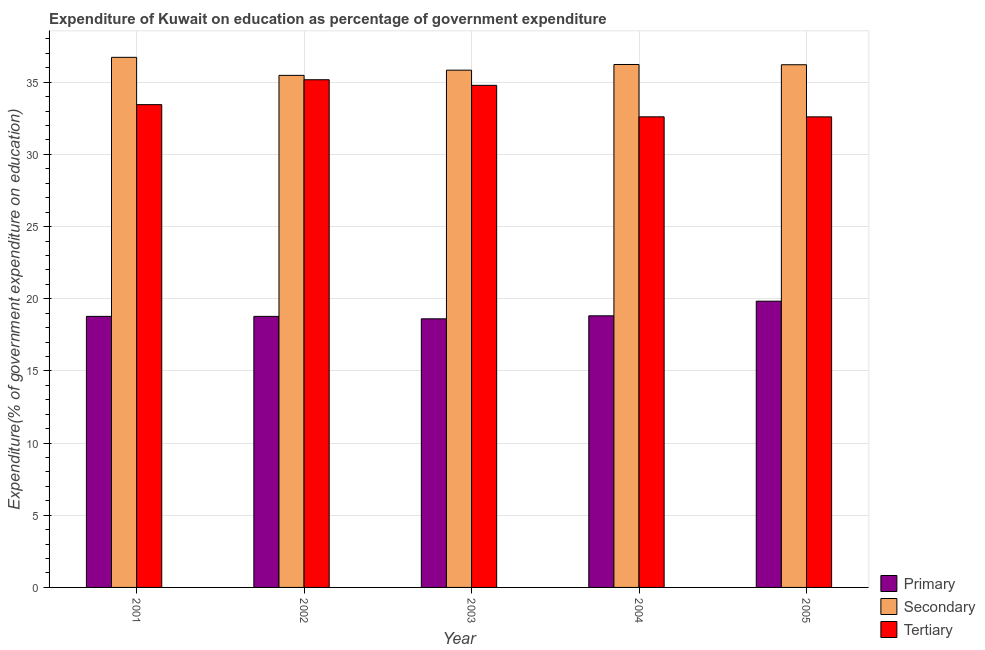How many different coloured bars are there?
Make the answer very short. 3. Are the number of bars on each tick of the X-axis equal?
Your response must be concise. Yes. How many bars are there on the 5th tick from the left?
Provide a succinct answer. 3. What is the expenditure on primary education in 2002?
Ensure brevity in your answer.  18.78. Across all years, what is the maximum expenditure on primary education?
Your response must be concise. 19.83. Across all years, what is the minimum expenditure on secondary education?
Offer a terse response. 35.48. In which year was the expenditure on secondary education maximum?
Give a very brief answer. 2001. In which year was the expenditure on primary education minimum?
Provide a short and direct response. 2003. What is the total expenditure on secondary education in the graph?
Provide a succinct answer. 180.48. What is the difference between the expenditure on tertiary education in 2003 and that in 2004?
Give a very brief answer. 2.18. What is the difference between the expenditure on primary education in 2003 and the expenditure on tertiary education in 2004?
Your response must be concise. -0.21. What is the average expenditure on tertiary education per year?
Give a very brief answer. 33.72. In the year 2001, what is the difference between the expenditure on secondary education and expenditure on tertiary education?
Offer a terse response. 0. In how many years, is the expenditure on tertiary education greater than 5 %?
Provide a short and direct response. 5. What is the ratio of the expenditure on tertiary education in 2001 to that in 2002?
Your answer should be very brief. 0.95. Is the difference between the expenditure on tertiary education in 2001 and 2004 greater than the difference between the expenditure on primary education in 2001 and 2004?
Your answer should be very brief. No. What is the difference between the highest and the second highest expenditure on tertiary education?
Provide a succinct answer. 0.39. What is the difference between the highest and the lowest expenditure on primary education?
Keep it short and to the point. 1.22. Is the sum of the expenditure on tertiary education in 2002 and 2003 greater than the maximum expenditure on secondary education across all years?
Your answer should be very brief. Yes. What does the 2nd bar from the left in 2001 represents?
Your answer should be very brief. Secondary. What does the 2nd bar from the right in 2004 represents?
Ensure brevity in your answer.  Secondary. Is it the case that in every year, the sum of the expenditure on primary education and expenditure on secondary education is greater than the expenditure on tertiary education?
Offer a very short reply. Yes. Are the values on the major ticks of Y-axis written in scientific E-notation?
Offer a terse response. No. Does the graph contain grids?
Offer a terse response. Yes. How many legend labels are there?
Keep it short and to the point. 3. How are the legend labels stacked?
Your response must be concise. Vertical. What is the title of the graph?
Your answer should be very brief. Expenditure of Kuwait on education as percentage of government expenditure. Does "Total employers" appear as one of the legend labels in the graph?
Your answer should be compact. No. What is the label or title of the X-axis?
Offer a very short reply. Year. What is the label or title of the Y-axis?
Your response must be concise. Expenditure(% of government expenditure on education). What is the Expenditure(% of government expenditure on education) of Primary in 2001?
Give a very brief answer. 18.78. What is the Expenditure(% of government expenditure on education) of Secondary in 2001?
Keep it short and to the point. 36.73. What is the Expenditure(% of government expenditure on education) of Tertiary in 2001?
Your answer should be compact. 33.45. What is the Expenditure(% of government expenditure on education) in Primary in 2002?
Your answer should be compact. 18.78. What is the Expenditure(% of government expenditure on education) in Secondary in 2002?
Your response must be concise. 35.48. What is the Expenditure(% of government expenditure on education) in Tertiary in 2002?
Your answer should be compact. 35.17. What is the Expenditure(% of government expenditure on education) of Primary in 2003?
Your answer should be compact. 18.61. What is the Expenditure(% of government expenditure on education) in Secondary in 2003?
Your response must be concise. 35.84. What is the Expenditure(% of government expenditure on education) of Tertiary in 2003?
Your answer should be compact. 34.79. What is the Expenditure(% of government expenditure on education) in Primary in 2004?
Give a very brief answer. 18.82. What is the Expenditure(% of government expenditure on education) of Secondary in 2004?
Your answer should be compact. 36.23. What is the Expenditure(% of government expenditure on education) of Tertiary in 2004?
Provide a short and direct response. 32.6. What is the Expenditure(% of government expenditure on education) in Primary in 2005?
Offer a terse response. 19.83. What is the Expenditure(% of government expenditure on education) in Secondary in 2005?
Give a very brief answer. 36.21. What is the Expenditure(% of government expenditure on education) of Tertiary in 2005?
Offer a very short reply. 32.6. Across all years, what is the maximum Expenditure(% of government expenditure on education) of Primary?
Ensure brevity in your answer.  19.83. Across all years, what is the maximum Expenditure(% of government expenditure on education) of Secondary?
Keep it short and to the point. 36.73. Across all years, what is the maximum Expenditure(% of government expenditure on education) in Tertiary?
Keep it short and to the point. 35.17. Across all years, what is the minimum Expenditure(% of government expenditure on education) in Primary?
Give a very brief answer. 18.61. Across all years, what is the minimum Expenditure(% of government expenditure on education) of Secondary?
Ensure brevity in your answer.  35.48. Across all years, what is the minimum Expenditure(% of government expenditure on education) in Tertiary?
Provide a succinct answer. 32.6. What is the total Expenditure(% of government expenditure on education) of Primary in the graph?
Your response must be concise. 94.81. What is the total Expenditure(% of government expenditure on education) in Secondary in the graph?
Give a very brief answer. 180.48. What is the total Expenditure(% of government expenditure on education) in Tertiary in the graph?
Provide a short and direct response. 168.61. What is the difference between the Expenditure(% of government expenditure on education) of Primary in 2001 and that in 2002?
Offer a terse response. 0. What is the difference between the Expenditure(% of government expenditure on education) of Secondary in 2001 and that in 2002?
Give a very brief answer. 1.25. What is the difference between the Expenditure(% of government expenditure on education) of Tertiary in 2001 and that in 2002?
Provide a succinct answer. -1.73. What is the difference between the Expenditure(% of government expenditure on education) of Primary in 2001 and that in 2003?
Your answer should be very brief. 0.17. What is the difference between the Expenditure(% of government expenditure on education) of Secondary in 2001 and that in 2003?
Offer a terse response. 0.89. What is the difference between the Expenditure(% of government expenditure on education) in Tertiary in 2001 and that in 2003?
Make the answer very short. -1.34. What is the difference between the Expenditure(% of government expenditure on education) in Primary in 2001 and that in 2004?
Offer a terse response. -0.04. What is the difference between the Expenditure(% of government expenditure on education) in Secondary in 2001 and that in 2004?
Offer a very short reply. 0.5. What is the difference between the Expenditure(% of government expenditure on education) in Tertiary in 2001 and that in 2004?
Your answer should be compact. 0.84. What is the difference between the Expenditure(% of government expenditure on education) in Primary in 2001 and that in 2005?
Ensure brevity in your answer.  -1.05. What is the difference between the Expenditure(% of government expenditure on education) of Secondary in 2001 and that in 2005?
Offer a terse response. 0.51. What is the difference between the Expenditure(% of government expenditure on education) of Tertiary in 2001 and that in 2005?
Make the answer very short. 0.85. What is the difference between the Expenditure(% of government expenditure on education) of Primary in 2002 and that in 2003?
Make the answer very short. 0.17. What is the difference between the Expenditure(% of government expenditure on education) in Secondary in 2002 and that in 2003?
Provide a short and direct response. -0.36. What is the difference between the Expenditure(% of government expenditure on education) in Tertiary in 2002 and that in 2003?
Give a very brief answer. 0.39. What is the difference between the Expenditure(% of government expenditure on education) in Primary in 2002 and that in 2004?
Your answer should be very brief. -0.04. What is the difference between the Expenditure(% of government expenditure on education) of Secondary in 2002 and that in 2004?
Provide a short and direct response. -0.75. What is the difference between the Expenditure(% of government expenditure on education) of Tertiary in 2002 and that in 2004?
Your answer should be very brief. 2.57. What is the difference between the Expenditure(% of government expenditure on education) in Primary in 2002 and that in 2005?
Provide a short and direct response. -1.05. What is the difference between the Expenditure(% of government expenditure on education) in Secondary in 2002 and that in 2005?
Keep it short and to the point. -0.74. What is the difference between the Expenditure(% of government expenditure on education) of Tertiary in 2002 and that in 2005?
Offer a terse response. 2.57. What is the difference between the Expenditure(% of government expenditure on education) in Primary in 2003 and that in 2004?
Your answer should be very brief. -0.21. What is the difference between the Expenditure(% of government expenditure on education) in Secondary in 2003 and that in 2004?
Your answer should be compact. -0.39. What is the difference between the Expenditure(% of government expenditure on education) in Tertiary in 2003 and that in 2004?
Your response must be concise. 2.18. What is the difference between the Expenditure(% of government expenditure on education) of Primary in 2003 and that in 2005?
Make the answer very short. -1.22. What is the difference between the Expenditure(% of government expenditure on education) of Secondary in 2003 and that in 2005?
Give a very brief answer. -0.38. What is the difference between the Expenditure(% of government expenditure on education) of Tertiary in 2003 and that in 2005?
Your answer should be very brief. 2.18. What is the difference between the Expenditure(% of government expenditure on education) in Primary in 2004 and that in 2005?
Ensure brevity in your answer.  -1.01. What is the difference between the Expenditure(% of government expenditure on education) of Secondary in 2004 and that in 2005?
Keep it short and to the point. 0.02. What is the difference between the Expenditure(% of government expenditure on education) of Tertiary in 2004 and that in 2005?
Provide a succinct answer. 0. What is the difference between the Expenditure(% of government expenditure on education) in Primary in 2001 and the Expenditure(% of government expenditure on education) in Secondary in 2002?
Provide a short and direct response. -16.7. What is the difference between the Expenditure(% of government expenditure on education) in Primary in 2001 and the Expenditure(% of government expenditure on education) in Tertiary in 2002?
Your response must be concise. -16.39. What is the difference between the Expenditure(% of government expenditure on education) in Secondary in 2001 and the Expenditure(% of government expenditure on education) in Tertiary in 2002?
Make the answer very short. 1.55. What is the difference between the Expenditure(% of government expenditure on education) in Primary in 2001 and the Expenditure(% of government expenditure on education) in Secondary in 2003?
Your answer should be compact. -17.06. What is the difference between the Expenditure(% of government expenditure on education) of Primary in 2001 and the Expenditure(% of government expenditure on education) of Tertiary in 2003?
Provide a succinct answer. -16.01. What is the difference between the Expenditure(% of government expenditure on education) in Secondary in 2001 and the Expenditure(% of government expenditure on education) in Tertiary in 2003?
Keep it short and to the point. 1.94. What is the difference between the Expenditure(% of government expenditure on education) in Primary in 2001 and the Expenditure(% of government expenditure on education) in Secondary in 2004?
Your response must be concise. -17.45. What is the difference between the Expenditure(% of government expenditure on education) of Primary in 2001 and the Expenditure(% of government expenditure on education) of Tertiary in 2004?
Your answer should be very brief. -13.82. What is the difference between the Expenditure(% of government expenditure on education) in Secondary in 2001 and the Expenditure(% of government expenditure on education) in Tertiary in 2004?
Provide a short and direct response. 4.12. What is the difference between the Expenditure(% of government expenditure on education) of Primary in 2001 and the Expenditure(% of government expenditure on education) of Secondary in 2005?
Provide a short and direct response. -17.43. What is the difference between the Expenditure(% of government expenditure on education) of Primary in 2001 and the Expenditure(% of government expenditure on education) of Tertiary in 2005?
Your response must be concise. -13.82. What is the difference between the Expenditure(% of government expenditure on education) in Secondary in 2001 and the Expenditure(% of government expenditure on education) in Tertiary in 2005?
Offer a very short reply. 4.12. What is the difference between the Expenditure(% of government expenditure on education) in Primary in 2002 and the Expenditure(% of government expenditure on education) in Secondary in 2003?
Ensure brevity in your answer.  -17.06. What is the difference between the Expenditure(% of government expenditure on education) in Primary in 2002 and the Expenditure(% of government expenditure on education) in Tertiary in 2003?
Offer a very short reply. -16.01. What is the difference between the Expenditure(% of government expenditure on education) in Secondary in 2002 and the Expenditure(% of government expenditure on education) in Tertiary in 2003?
Your answer should be very brief. 0.69. What is the difference between the Expenditure(% of government expenditure on education) of Primary in 2002 and the Expenditure(% of government expenditure on education) of Secondary in 2004?
Make the answer very short. -17.45. What is the difference between the Expenditure(% of government expenditure on education) of Primary in 2002 and the Expenditure(% of government expenditure on education) of Tertiary in 2004?
Provide a succinct answer. -13.82. What is the difference between the Expenditure(% of government expenditure on education) of Secondary in 2002 and the Expenditure(% of government expenditure on education) of Tertiary in 2004?
Your response must be concise. 2.87. What is the difference between the Expenditure(% of government expenditure on education) of Primary in 2002 and the Expenditure(% of government expenditure on education) of Secondary in 2005?
Keep it short and to the point. -17.43. What is the difference between the Expenditure(% of government expenditure on education) of Primary in 2002 and the Expenditure(% of government expenditure on education) of Tertiary in 2005?
Provide a succinct answer. -13.82. What is the difference between the Expenditure(% of government expenditure on education) of Secondary in 2002 and the Expenditure(% of government expenditure on education) of Tertiary in 2005?
Provide a short and direct response. 2.88. What is the difference between the Expenditure(% of government expenditure on education) in Primary in 2003 and the Expenditure(% of government expenditure on education) in Secondary in 2004?
Offer a terse response. -17.62. What is the difference between the Expenditure(% of government expenditure on education) of Primary in 2003 and the Expenditure(% of government expenditure on education) of Tertiary in 2004?
Offer a very short reply. -13.99. What is the difference between the Expenditure(% of government expenditure on education) in Secondary in 2003 and the Expenditure(% of government expenditure on education) in Tertiary in 2004?
Keep it short and to the point. 3.23. What is the difference between the Expenditure(% of government expenditure on education) in Primary in 2003 and the Expenditure(% of government expenditure on education) in Secondary in 2005?
Your answer should be very brief. -17.6. What is the difference between the Expenditure(% of government expenditure on education) of Primary in 2003 and the Expenditure(% of government expenditure on education) of Tertiary in 2005?
Offer a very short reply. -13.99. What is the difference between the Expenditure(% of government expenditure on education) of Secondary in 2003 and the Expenditure(% of government expenditure on education) of Tertiary in 2005?
Provide a succinct answer. 3.24. What is the difference between the Expenditure(% of government expenditure on education) in Primary in 2004 and the Expenditure(% of government expenditure on education) in Secondary in 2005?
Provide a short and direct response. -17.39. What is the difference between the Expenditure(% of government expenditure on education) of Primary in 2004 and the Expenditure(% of government expenditure on education) of Tertiary in 2005?
Keep it short and to the point. -13.78. What is the difference between the Expenditure(% of government expenditure on education) in Secondary in 2004 and the Expenditure(% of government expenditure on education) in Tertiary in 2005?
Your answer should be compact. 3.63. What is the average Expenditure(% of government expenditure on education) of Primary per year?
Your response must be concise. 18.96. What is the average Expenditure(% of government expenditure on education) of Secondary per year?
Offer a terse response. 36.1. What is the average Expenditure(% of government expenditure on education) of Tertiary per year?
Make the answer very short. 33.72. In the year 2001, what is the difference between the Expenditure(% of government expenditure on education) in Primary and Expenditure(% of government expenditure on education) in Secondary?
Provide a short and direct response. -17.95. In the year 2001, what is the difference between the Expenditure(% of government expenditure on education) of Primary and Expenditure(% of government expenditure on education) of Tertiary?
Make the answer very short. -14.67. In the year 2001, what is the difference between the Expenditure(% of government expenditure on education) of Secondary and Expenditure(% of government expenditure on education) of Tertiary?
Ensure brevity in your answer.  3.28. In the year 2002, what is the difference between the Expenditure(% of government expenditure on education) of Primary and Expenditure(% of government expenditure on education) of Secondary?
Offer a terse response. -16.7. In the year 2002, what is the difference between the Expenditure(% of government expenditure on education) of Primary and Expenditure(% of government expenditure on education) of Tertiary?
Provide a succinct answer. -16.39. In the year 2002, what is the difference between the Expenditure(% of government expenditure on education) in Secondary and Expenditure(% of government expenditure on education) in Tertiary?
Offer a terse response. 0.3. In the year 2003, what is the difference between the Expenditure(% of government expenditure on education) in Primary and Expenditure(% of government expenditure on education) in Secondary?
Provide a succinct answer. -17.23. In the year 2003, what is the difference between the Expenditure(% of government expenditure on education) of Primary and Expenditure(% of government expenditure on education) of Tertiary?
Your response must be concise. -16.18. In the year 2003, what is the difference between the Expenditure(% of government expenditure on education) of Secondary and Expenditure(% of government expenditure on education) of Tertiary?
Provide a short and direct response. 1.05. In the year 2004, what is the difference between the Expenditure(% of government expenditure on education) of Primary and Expenditure(% of government expenditure on education) of Secondary?
Offer a terse response. -17.41. In the year 2004, what is the difference between the Expenditure(% of government expenditure on education) in Primary and Expenditure(% of government expenditure on education) in Tertiary?
Your answer should be very brief. -13.79. In the year 2004, what is the difference between the Expenditure(% of government expenditure on education) of Secondary and Expenditure(% of government expenditure on education) of Tertiary?
Your response must be concise. 3.63. In the year 2005, what is the difference between the Expenditure(% of government expenditure on education) of Primary and Expenditure(% of government expenditure on education) of Secondary?
Give a very brief answer. -16.38. In the year 2005, what is the difference between the Expenditure(% of government expenditure on education) of Primary and Expenditure(% of government expenditure on education) of Tertiary?
Keep it short and to the point. -12.77. In the year 2005, what is the difference between the Expenditure(% of government expenditure on education) of Secondary and Expenditure(% of government expenditure on education) of Tertiary?
Keep it short and to the point. 3.61. What is the ratio of the Expenditure(% of government expenditure on education) of Primary in 2001 to that in 2002?
Provide a short and direct response. 1. What is the ratio of the Expenditure(% of government expenditure on education) in Secondary in 2001 to that in 2002?
Offer a terse response. 1.04. What is the ratio of the Expenditure(% of government expenditure on education) in Tertiary in 2001 to that in 2002?
Your answer should be compact. 0.95. What is the ratio of the Expenditure(% of government expenditure on education) in Primary in 2001 to that in 2003?
Give a very brief answer. 1.01. What is the ratio of the Expenditure(% of government expenditure on education) in Secondary in 2001 to that in 2003?
Provide a succinct answer. 1.02. What is the ratio of the Expenditure(% of government expenditure on education) in Tertiary in 2001 to that in 2003?
Offer a very short reply. 0.96. What is the ratio of the Expenditure(% of government expenditure on education) of Secondary in 2001 to that in 2004?
Provide a succinct answer. 1.01. What is the ratio of the Expenditure(% of government expenditure on education) of Tertiary in 2001 to that in 2004?
Provide a succinct answer. 1.03. What is the ratio of the Expenditure(% of government expenditure on education) of Primary in 2001 to that in 2005?
Your answer should be very brief. 0.95. What is the ratio of the Expenditure(% of government expenditure on education) of Secondary in 2001 to that in 2005?
Offer a very short reply. 1.01. What is the ratio of the Expenditure(% of government expenditure on education) of Primary in 2002 to that in 2003?
Your answer should be compact. 1.01. What is the ratio of the Expenditure(% of government expenditure on education) of Tertiary in 2002 to that in 2003?
Provide a short and direct response. 1.01. What is the ratio of the Expenditure(% of government expenditure on education) of Secondary in 2002 to that in 2004?
Ensure brevity in your answer.  0.98. What is the ratio of the Expenditure(% of government expenditure on education) in Tertiary in 2002 to that in 2004?
Provide a succinct answer. 1.08. What is the ratio of the Expenditure(% of government expenditure on education) in Primary in 2002 to that in 2005?
Your answer should be compact. 0.95. What is the ratio of the Expenditure(% of government expenditure on education) of Secondary in 2002 to that in 2005?
Ensure brevity in your answer.  0.98. What is the ratio of the Expenditure(% of government expenditure on education) in Tertiary in 2002 to that in 2005?
Give a very brief answer. 1.08. What is the ratio of the Expenditure(% of government expenditure on education) in Primary in 2003 to that in 2004?
Keep it short and to the point. 0.99. What is the ratio of the Expenditure(% of government expenditure on education) of Secondary in 2003 to that in 2004?
Offer a very short reply. 0.99. What is the ratio of the Expenditure(% of government expenditure on education) in Tertiary in 2003 to that in 2004?
Ensure brevity in your answer.  1.07. What is the ratio of the Expenditure(% of government expenditure on education) of Primary in 2003 to that in 2005?
Provide a succinct answer. 0.94. What is the ratio of the Expenditure(% of government expenditure on education) in Tertiary in 2003 to that in 2005?
Provide a short and direct response. 1.07. What is the ratio of the Expenditure(% of government expenditure on education) in Primary in 2004 to that in 2005?
Your answer should be compact. 0.95. What is the ratio of the Expenditure(% of government expenditure on education) in Secondary in 2004 to that in 2005?
Offer a very short reply. 1. What is the difference between the highest and the second highest Expenditure(% of government expenditure on education) in Primary?
Offer a very short reply. 1.01. What is the difference between the highest and the second highest Expenditure(% of government expenditure on education) of Secondary?
Make the answer very short. 0.5. What is the difference between the highest and the second highest Expenditure(% of government expenditure on education) in Tertiary?
Your answer should be very brief. 0.39. What is the difference between the highest and the lowest Expenditure(% of government expenditure on education) of Primary?
Offer a very short reply. 1.22. What is the difference between the highest and the lowest Expenditure(% of government expenditure on education) of Secondary?
Provide a succinct answer. 1.25. What is the difference between the highest and the lowest Expenditure(% of government expenditure on education) in Tertiary?
Make the answer very short. 2.57. 